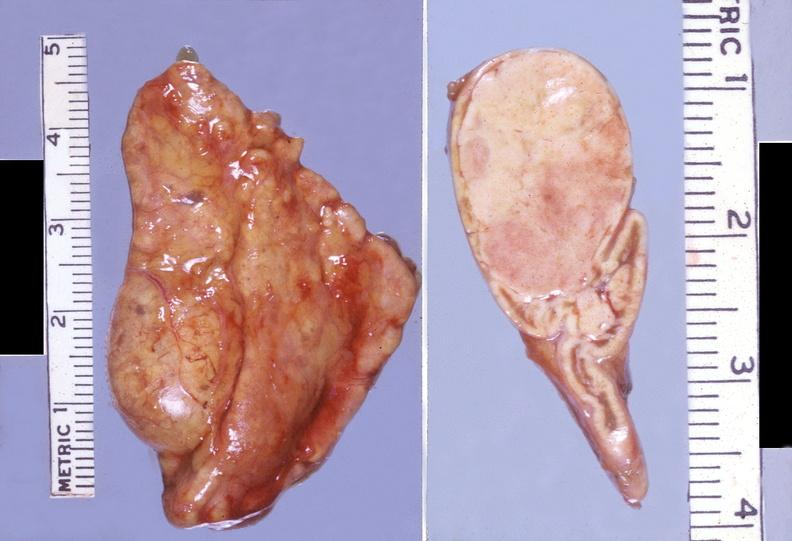what is present?
Answer the question using a single word or phrase. Endocrine 